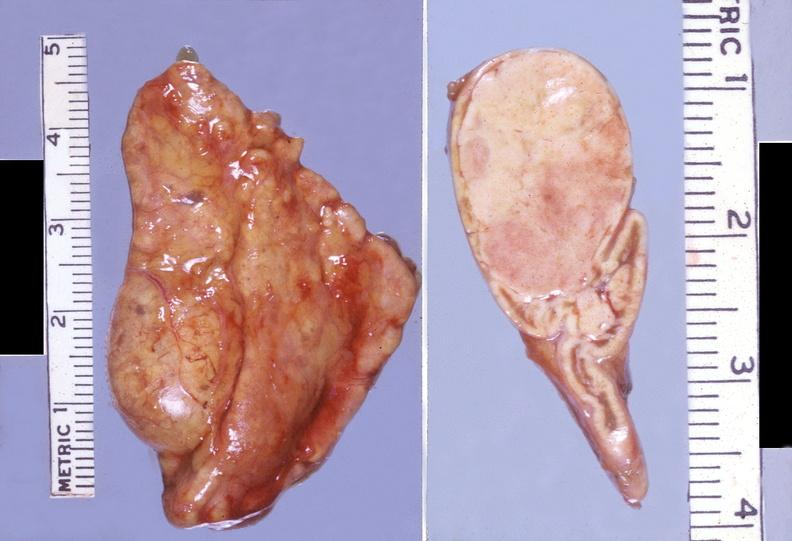what is present?
Answer the question using a single word or phrase. Endocrine 